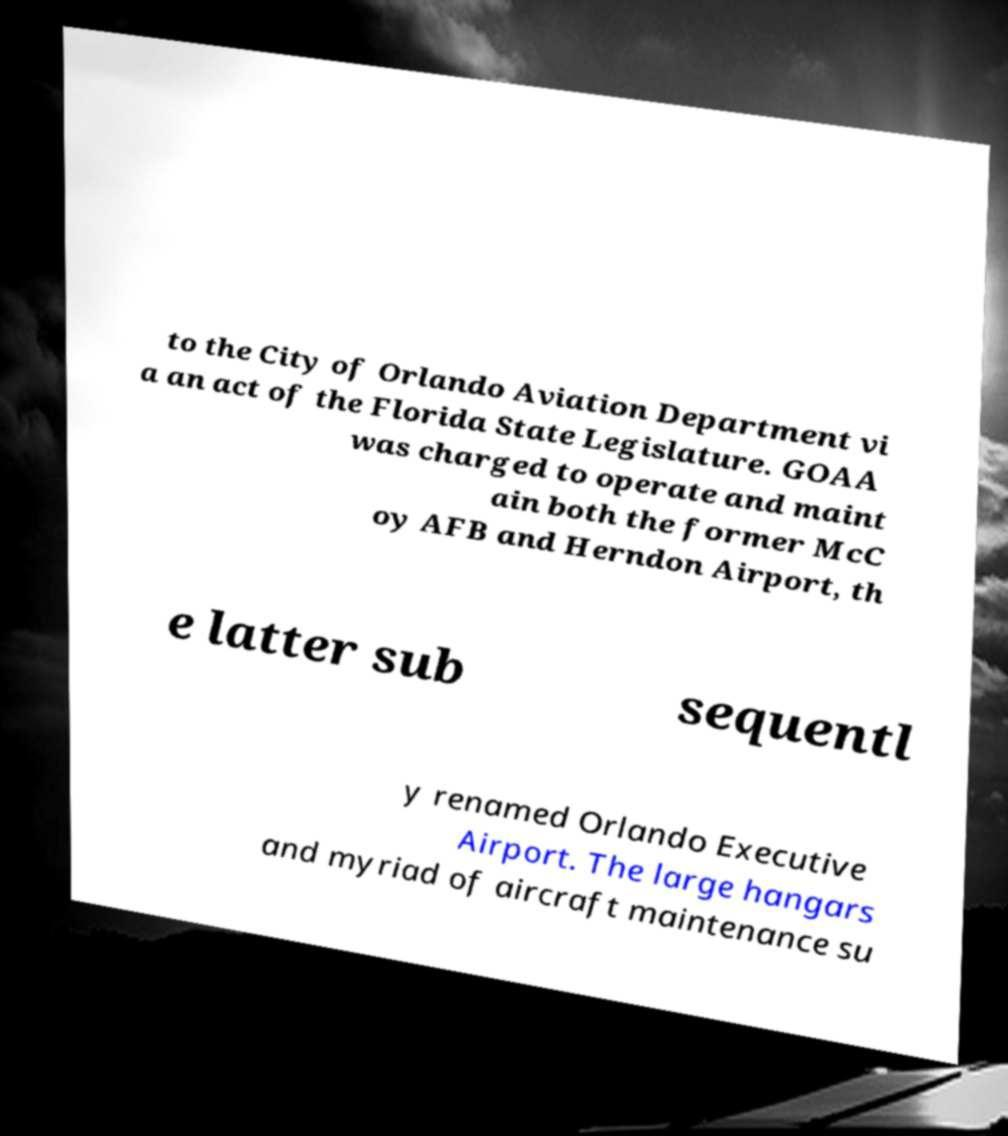There's text embedded in this image that I need extracted. Can you transcribe it verbatim? to the City of Orlando Aviation Department vi a an act of the Florida State Legislature. GOAA was charged to operate and maint ain both the former McC oy AFB and Herndon Airport, th e latter sub sequentl y renamed Orlando Executive Airport. The large hangars and myriad of aircraft maintenance su 